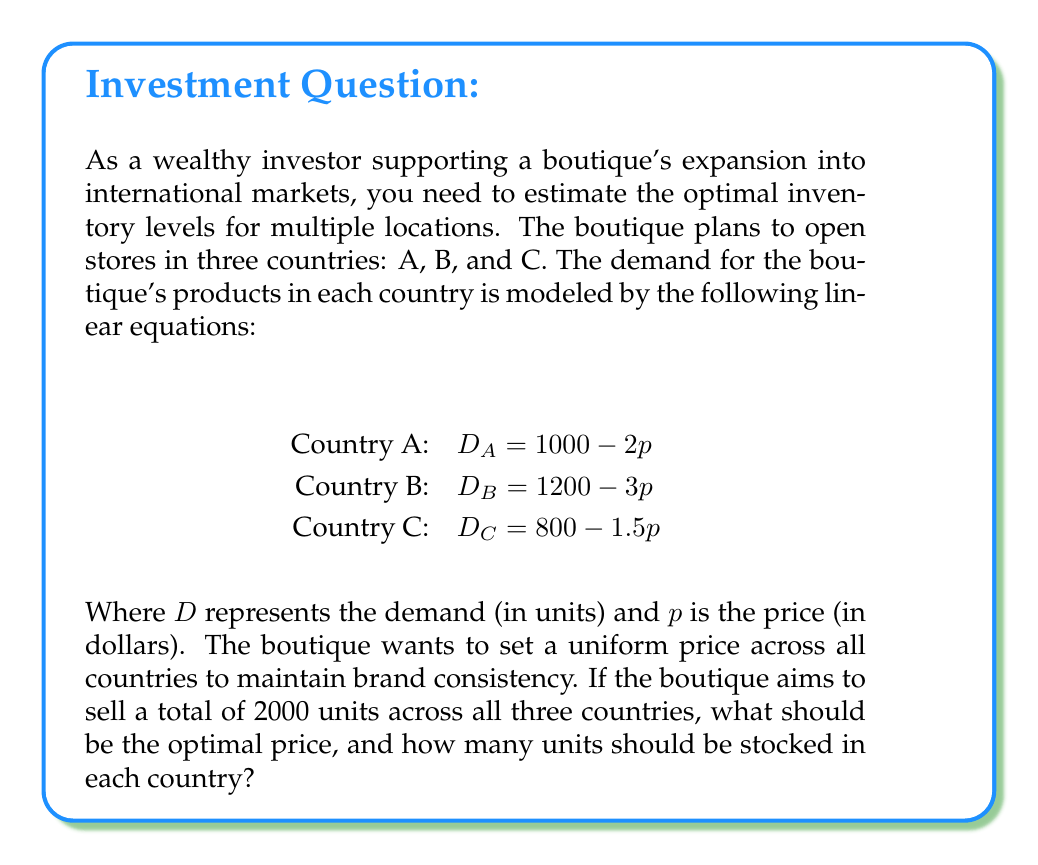Teach me how to tackle this problem. To solve this problem, we'll follow these steps:

1. Set up an equation for total demand across all countries:
   $$D_{total} = D_A + D_B + D_C = 2000$$

2. Substitute the demand equations for each country:
   $$(1000 - 2p) + (1200 - 3p) + (800 - 1.5p) = 2000$$

3. Simplify the equation:
   $$3000 - 6.5p = 2000$$

4. Solve for $p$:
   $$-6.5p = -1000$$
   $$p = \frac{1000}{6.5} \approx 153.85$$

5. Round the price to the nearest whole dollar: $p = 154$

6. Calculate the demand for each country using the rounded price:
   Country A: $D_A = 1000 - 2(154) = 692$ units
   Country B: $D_B = 1200 - 3(154) = 738$ units
   Country C: $D_C = 800 - 1.5(154) = 569$ units

7. Verify the total demand:
   $$692 + 738 + 569 = 1999$$ (which is close enough to 2000 given rounding)

Therefore, the optimal price should be set at $154, and the inventory levels for each country should be:
Country A: 692 units
Country B: 738 units
Country C: 569 units
Answer: Optimal price: $154
Inventory levels:
Country A: 692 units
Country B: 738 units
Country C: 569 units 